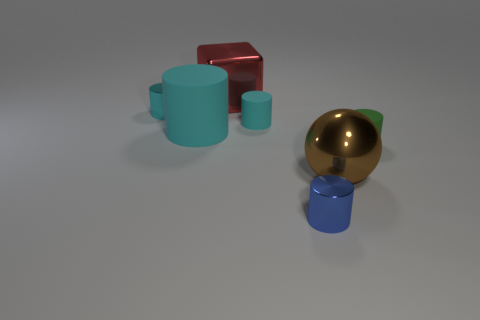Are there any other cyan objects that have the same shape as the big cyan object?
Make the answer very short. Yes. There is a green matte object; is it the same shape as the metal object that is in front of the ball?
Your answer should be compact. Yes. What is the size of the cyan metallic thing that is the same shape as the small blue object?
Offer a very short reply. Small. There is a cyan matte object that is left of the small cyan matte cylinder; is it the same shape as the thing to the right of the brown metallic ball?
Keep it short and to the point. Yes. Does the red thing have the same size as the blue cylinder in front of the brown sphere?
Your response must be concise. No. How many other things are there of the same material as the green thing?
Your response must be concise. 2. Is there any other thing that is the same shape as the brown metallic thing?
Keep it short and to the point. No. There is a small matte thing behind the tiny thing on the right side of the big metallic object in front of the tiny cyan rubber cylinder; what is its color?
Your answer should be compact. Cyan. What is the shape of the small thing that is left of the blue metallic cylinder and to the right of the large cyan cylinder?
Your response must be concise. Cylinder. Is there any other thing that has the same size as the brown object?
Your answer should be very brief. Yes. 